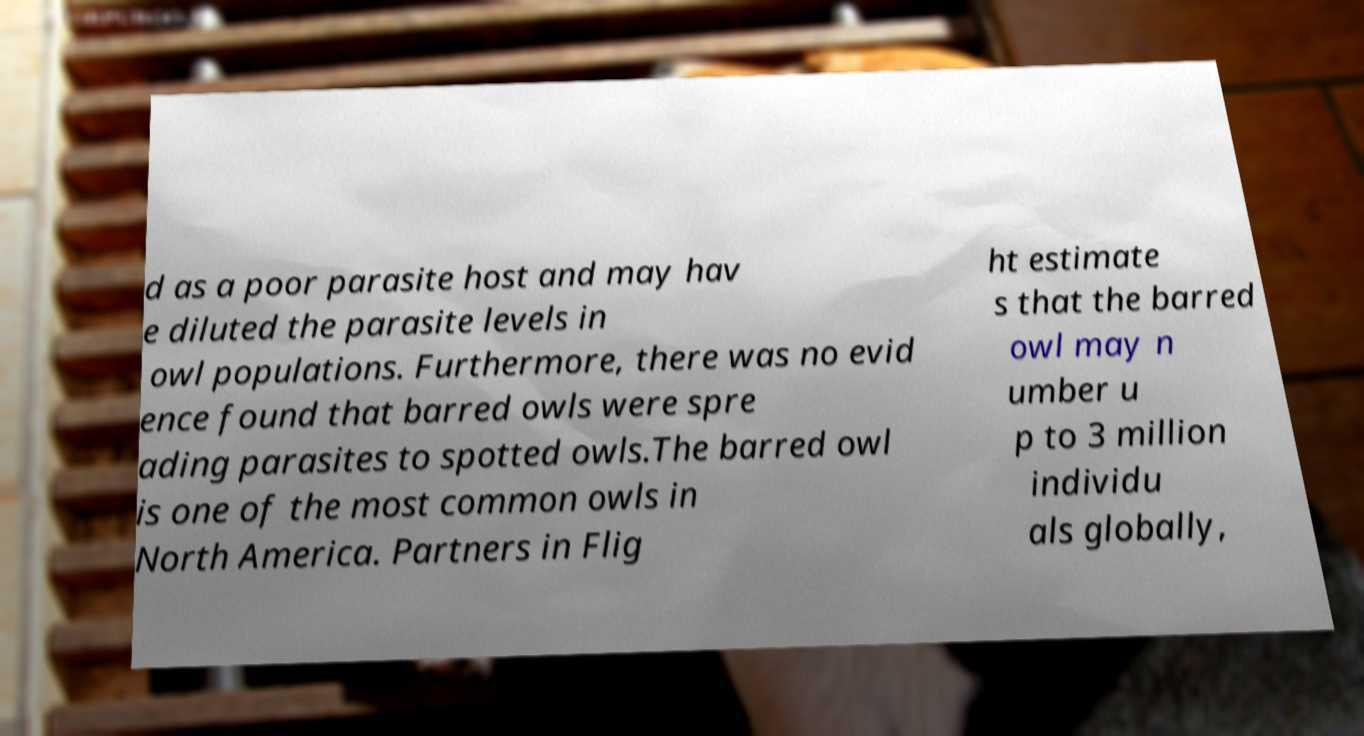Could you extract and type out the text from this image? d as a poor parasite host and may hav e diluted the parasite levels in owl populations. Furthermore, there was no evid ence found that barred owls were spre ading parasites to spotted owls.The barred owl is one of the most common owls in North America. Partners in Flig ht estimate s that the barred owl may n umber u p to 3 million individu als globally, 